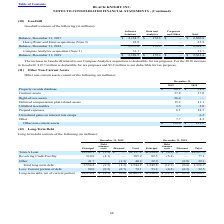According to Black Knight Financial Services's financial document, For the 2018 increase in Goodwill, how much was deductible for tax purposes? According to the financial document, 19.7 (in millions). The relevant text states: "in Goodwill, $19.7 million is deductible for tax purposes and $3.2 million is not deductible for tax purposes...." Also, What was the balance in 2017 for Software Solutions? According to the financial document, 2,134.7 (in millions). The relevant text states: "Balance, December 31, 2017 $ 2,134.7 $ 172.1 $ — $ 2,306.8..." Also, What was the total balance in 2019? According to the financial document, 2,361.4 (in millions). The relevant text states: "alance, December 31, 2019 $ 2,189.3 $ 172.1 $ — $ 2,361.4..." Also, can you calculate: What was the change in the balance of software solutions between 2017 and 2018? Based on the calculation: 2,157.6-2,134.7, the result is 22.9 (in millions). This is based on the information: "Balance, December 31, 2017 $ 2,134.7 $ 172.1 $ — $ 2,306.8 Balance, December 31, 2018 2,157.6 172.1 — 2,329.7..." The key data points involved are: 2,134.7, 2,157.6. Also, can you calculate: What was the difference in the total between HeavyWater and Ernst acquisitions and Compass Analytics acquisition? Based on the calculation: 31.7-22.9, the result is 8.8 (in millions). This is based on the information: "HeavyWater and Ernst acquisitions (Note 3) 22.9 — — 22.9 Compass Analytics acquisition (Note 3) 31.7 — — 31.7..." The key data points involved are: 22.9, 31.7. Also, can you calculate: What was the percentage change in total balance between 2018 and 2019? To answer this question, I need to perform calculations using the financial data. The calculation is: (2,361.4-2,329.7)/2,329.7, which equals 1.36 (percentage). This is based on the information: "alance, December 31, 2019 $ 2,189.3 $ 172.1 $ — $ 2,361.4 Balance, December 31, 2018 2,157.6 172.1 — 2,329.7..." The key data points involved are: 2,329.7, 2,361.4. 